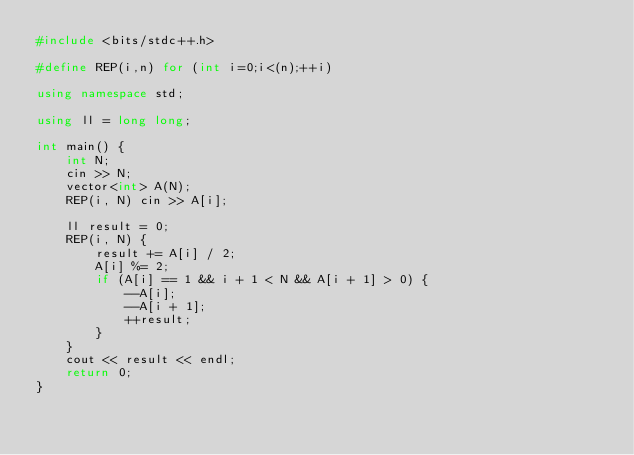Convert code to text. <code><loc_0><loc_0><loc_500><loc_500><_C++_>#include <bits/stdc++.h>

#define REP(i,n) for (int i=0;i<(n);++i)

using namespace std;

using ll = long long;

int main() {
    int N;
    cin >> N;
    vector<int> A(N);
    REP(i, N) cin >> A[i];

    ll result = 0;
    REP(i, N) {
        result += A[i] / 2;
        A[i] %= 2;
        if (A[i] == 1 && i + 1 < N && A[i + 1] > 0) {
            --A[i];
            --A[i + 1];
            ++result;
        }
    }
    cout << result << endl;
    return 0;
}</code> 